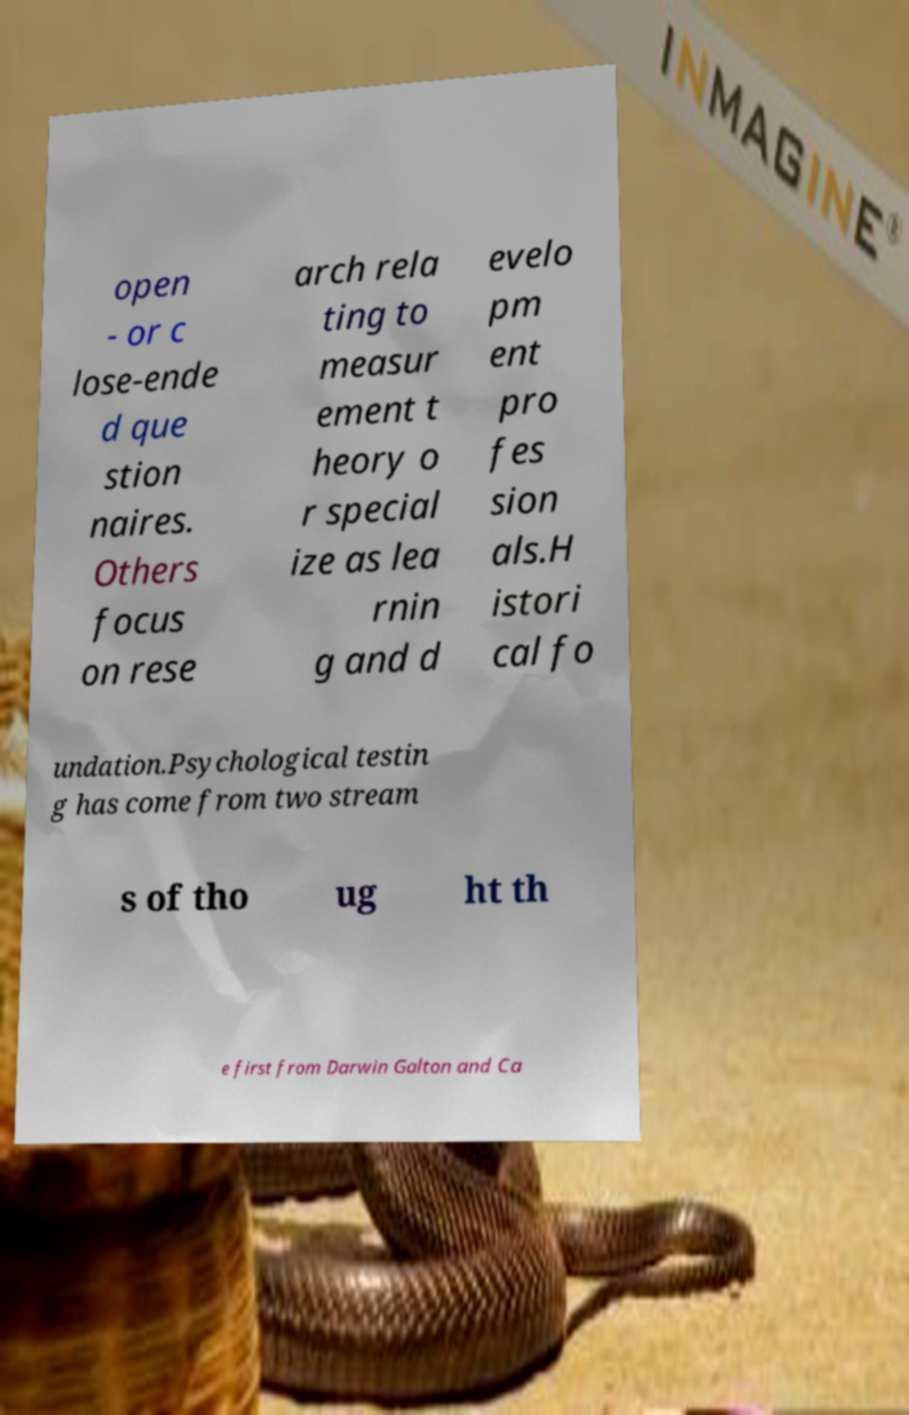Please read and relay the text visible in this image. What does it say? open - or c lose-ende d que stion naires. Others focus on rese arch rela ting to measur ement t heory o r special ize as lea rnin g and d evelo pm ent pro fes sion als.H istori cal fo undation.Psychological testin g has come from two stream s of tho ug ht th e first from Darwin Galton and Ca 